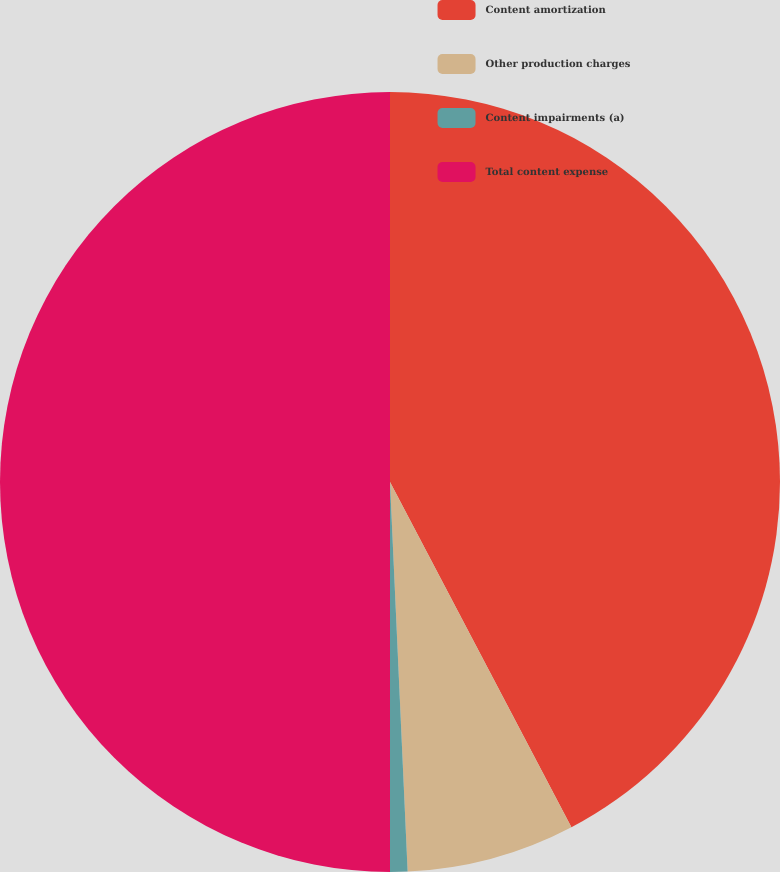Convert chart. <chart><loc_0><loc_0><loc_500><loc_500><pie_chart><fcel>Content amortization<fcel>Other production charges<fcel>Content impairments (a)<fcel>Total content expense<nl><fcel>42.3%<fcel>6.98%<fcel>0.72%<fcel>50.0%<nl></chart> 